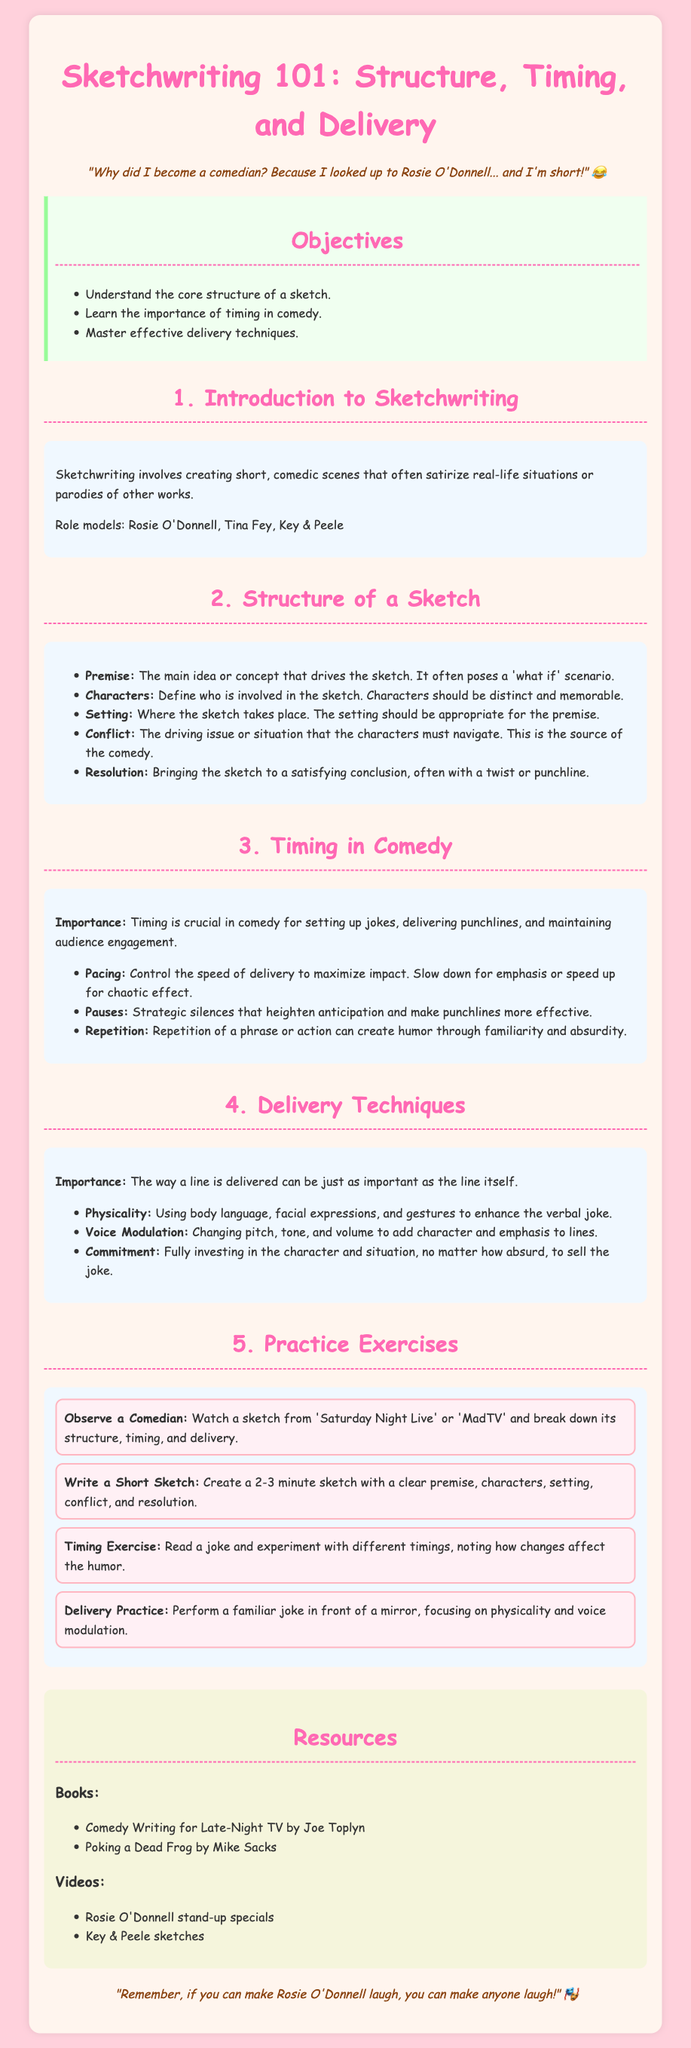What are the objectives of the lesson? The objectives are listed in a specific section of the document, highlighting the key goals of the lesson.
Answer: Understand the core structure of a sketch, Learn the importance of timing in comedy, Master effective delivery techniques Who is mentioned as a role model in sketchwriting? The document notes role models who have made significant contributions to comedy, highlighting influential figures.
Answer: Rosie O'Donnell, Tina Fey, Key & Peele What is the first element of a sketch's structure? The elements of structure are provided in a list, starting with the fundamental component.
Answer: Premise What is one technique mentioned for effective delivery? The delivery techniques section lists various methods for enhancing comedic performance, highlighting the importance of one specific aspect.
Answer: Physicality How many practice exercises are provided in the lesson? The practice exercises section can be counted to determine the total number.
Answer: Four What is emphasized as crucial in comedy? The document discusses the importance of specific elements in comedy, particularly one that is fundamental for timing.
Answer: Timing What is one book recommended for learning comedy writing? The resources section provides names of books that can help enhance comedy writing skills.
Answer: Comedy Writing for Late-Night TV by Joe Toplyn What should you observe during the first practice exercise? The first practice exercise specifies a particular type of performance to analyze for learning purposes.
Answer: A comedian 